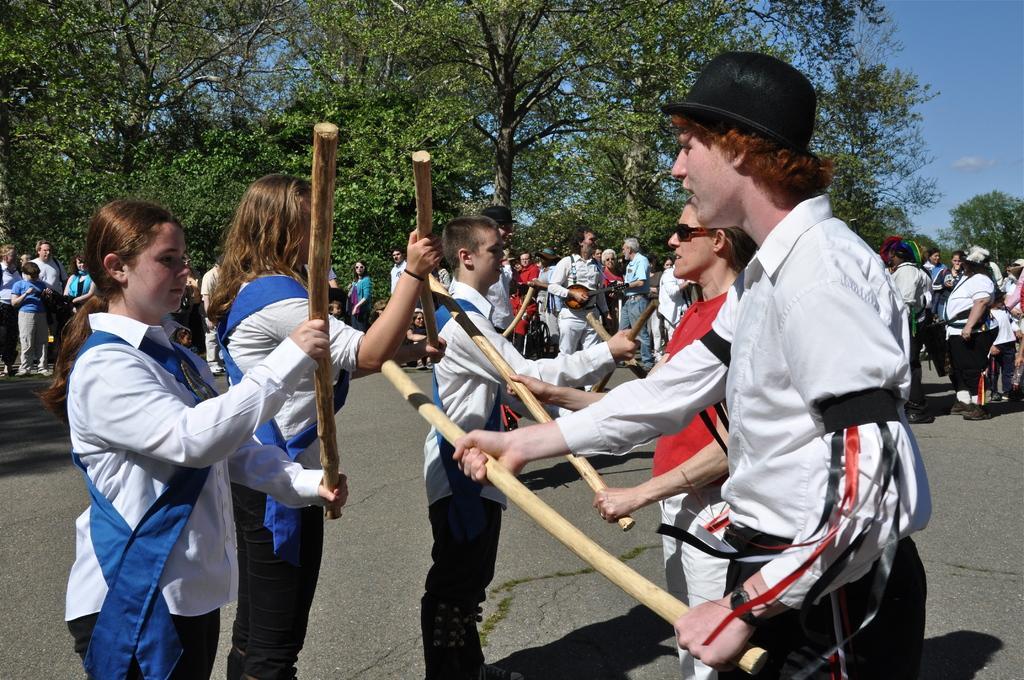In one or two sentences, can you explain what this image depicts? In the image in the center we can see few people were standing and holding sticks. In the background we can see sky,clouds,trees,road,group of people were standing and few people were holding some objects. 